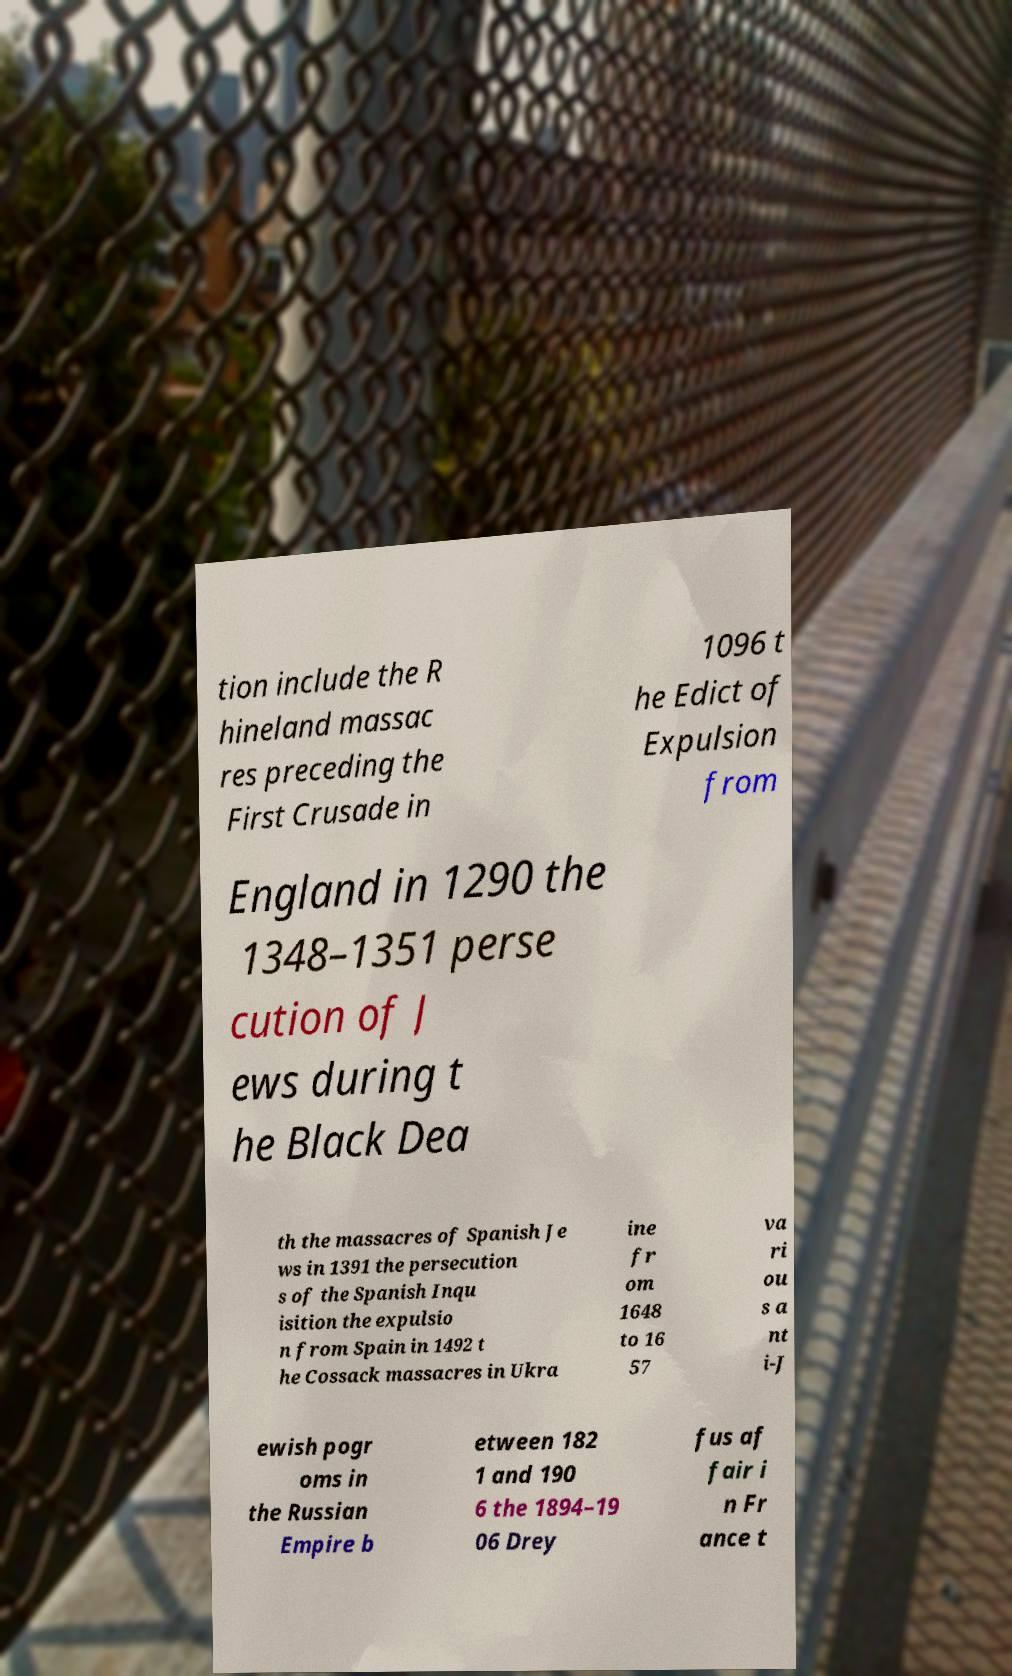Please read and relay the text visible in this image. What does it say? tion include the R hineland massac res preceding the First Crusade in 1096 t he Edict of Expulsion from England in 1290 the 1348–1351 perse cution of J ews during t he Black Dea th the massacres of Spanish Je ws in 1391 the persecution s of the Spanish Inqu isition the expulsio n from Spain in 1492 t he Cossack massacres in Ukra ine fr om 1648 to 16 57 va ri ou s a nt i-J ewish pogr oms in the Russian Empire b etween 182 1 and 190 6 the 1894–19 06 Drey fus af fair i n Fr ance t 